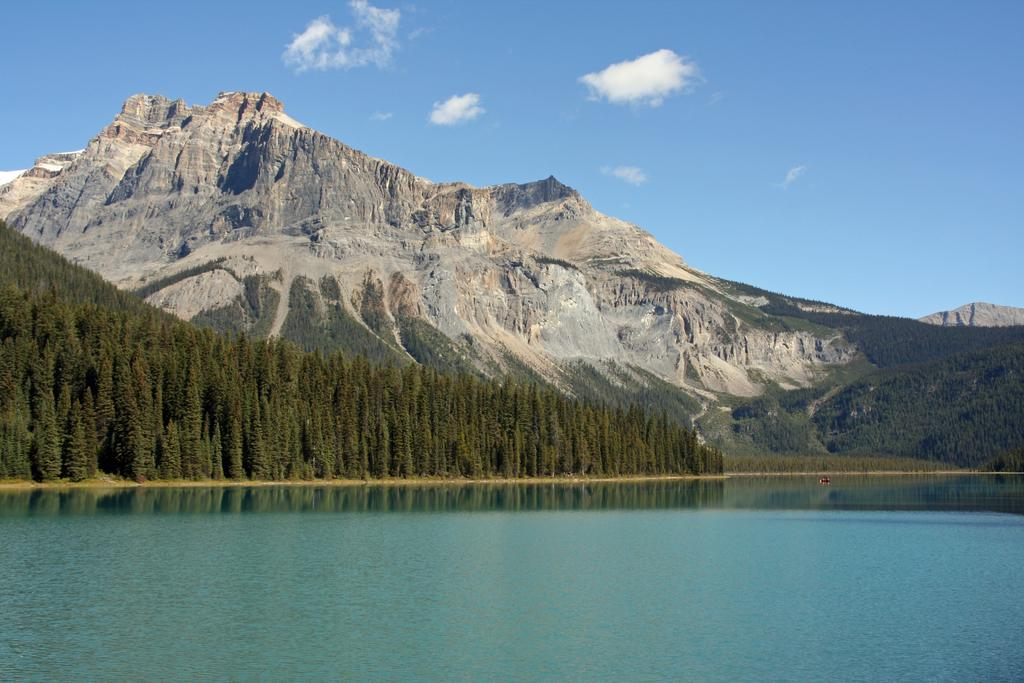What is visible in the image? Water is visible in the image. What can be seen in the background of the image? There are plants and the sky visible in the background of the image. What is the color of the plants in the image? The plants are green in color. What colors are present in the sky in the image? The sky is blue and white in color. How many pets are lying on the quilt in the image? There are no pets or quilts present in the image. 